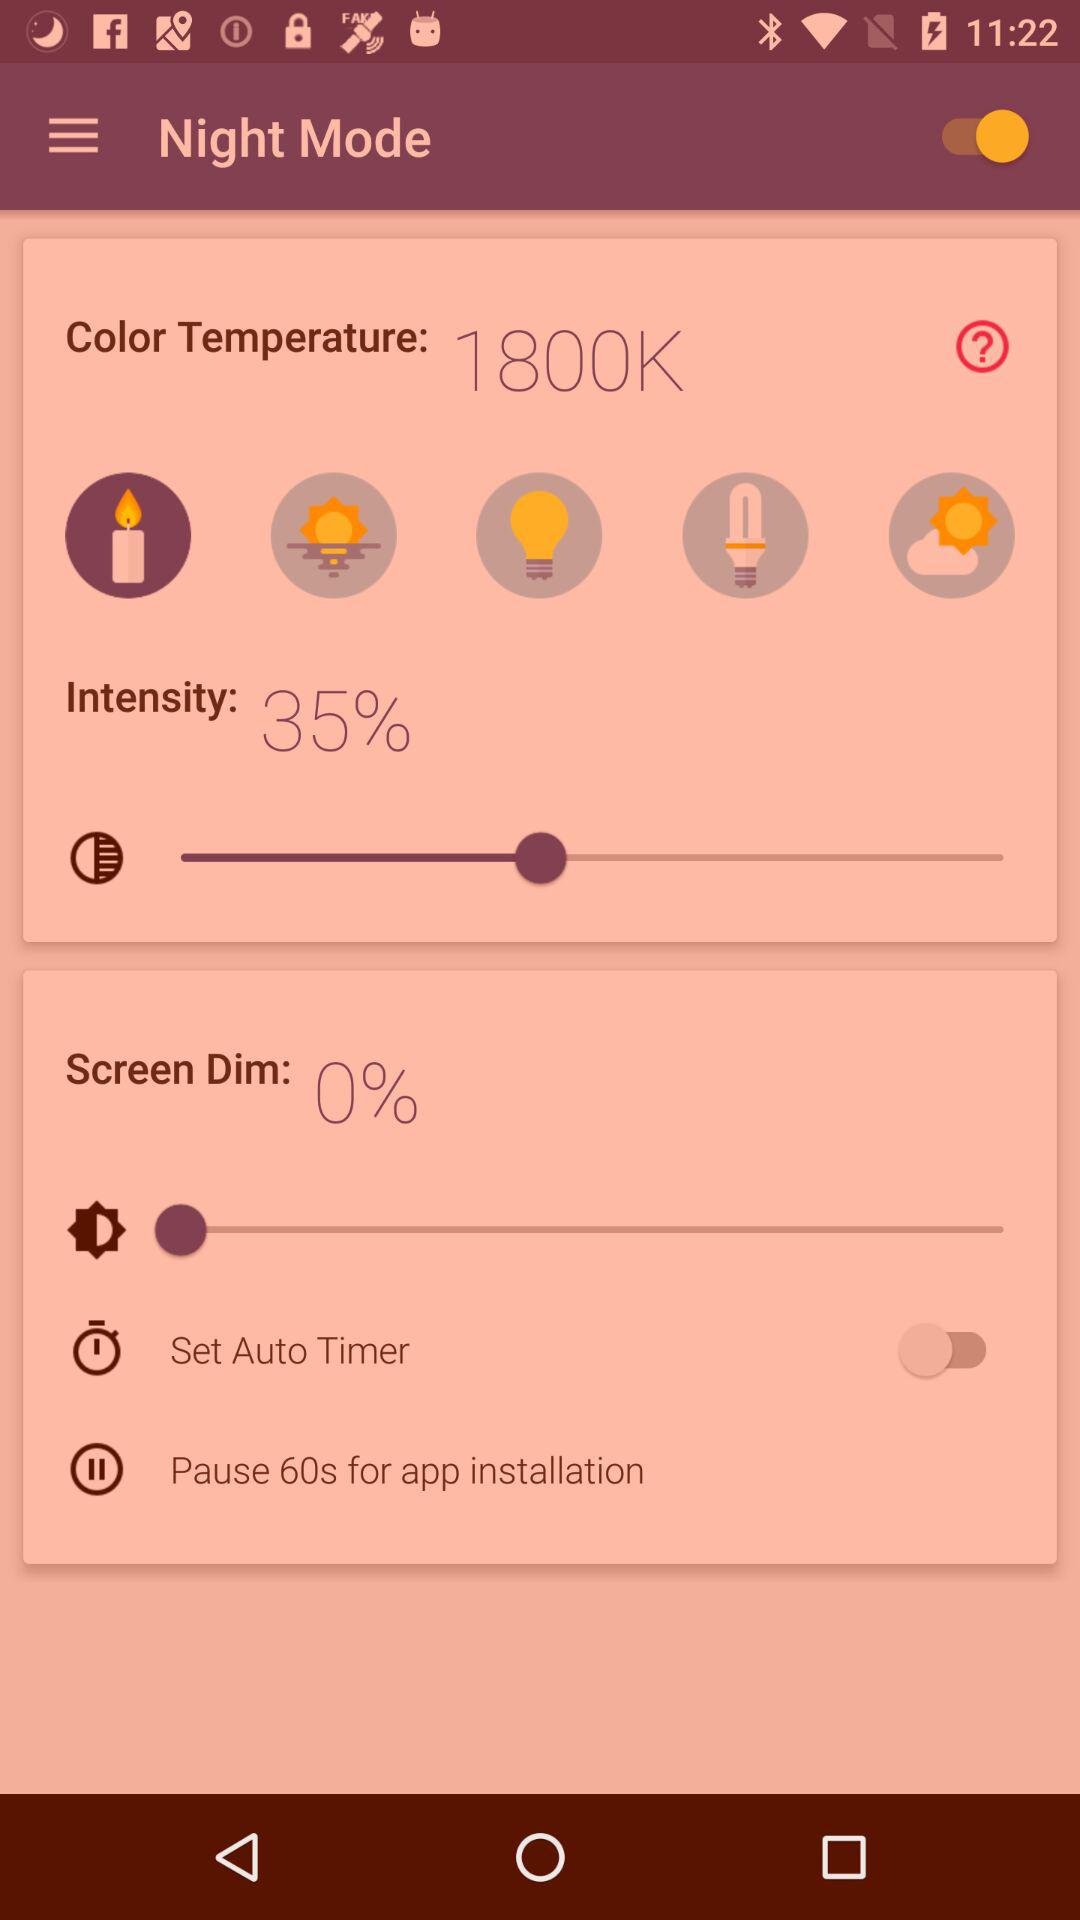What is the color temperature? The color temperature is 1800K. 